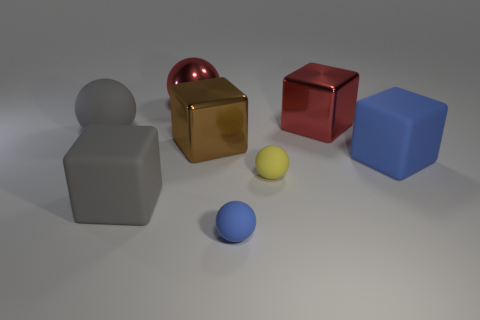Subtract 1 spheres. How many spheres are left? 3 Add 2 large red shiny spheres. How many objects exist? 10 Add 2 big red spheres. How many big red spheres are left? 3 Add 2 large green shiny cylinders. How many large green shiny cylinders exist? 2 Subtract 0 yellow cylinders. How many objects are left? 8 Subtract all red metal spheres. Subtract all big cubes. How many objects are left? 3 